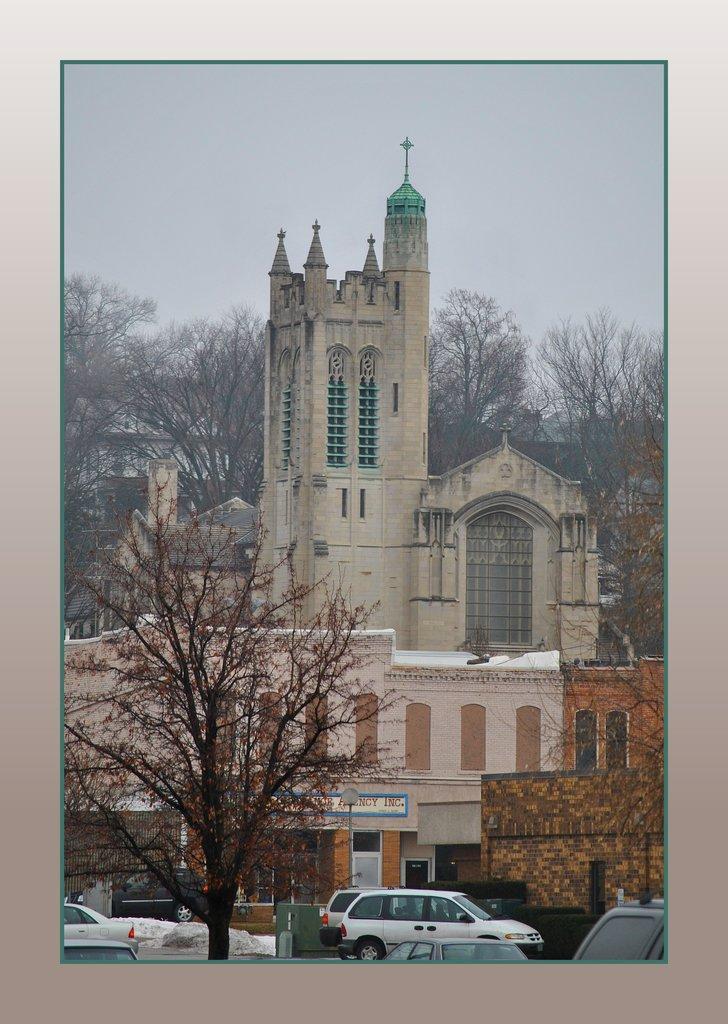Can you describe this image briefly? In this image we can see cars, trees and buildings. 